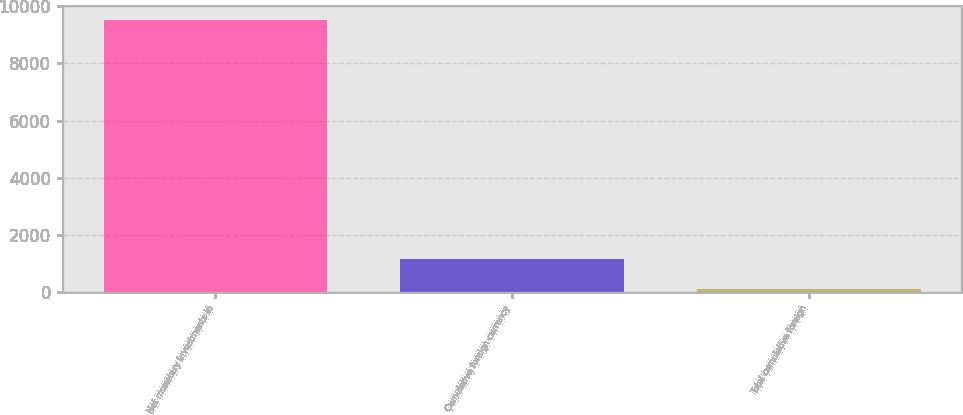<chart> <loc_0><loc_0><loc_500><loc_500><bar_chart><fcel>Net monetary investments in<fcel>Cumulative foreign currency<fcel>Total cumulative foreign<nl><fcel>9534<fcel>1176<fcel>114<nl></chart> 